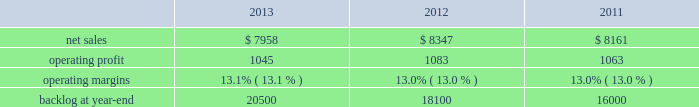Frequency ( aehf ) system , orion , global positioning satellite ( gps ) iii system , geostationary operational environmental satellite r-series ( goes-r ) , and mobile user objective system ( muos ) .
Operating profit for our space systems business segment includes our share of earnings for our investment in united launch alliance ( ula ) , which provides expendable launch services to the u.s .
Government .
Space systems 2019 operating results included the following ( in millions ) : .
2013 compared to 2012 space systems 2019 net sales for 2013 decreased $ 389 million , or 5% ( 5 % ) , compared to 2012 .
The decrease was primarily attributable to lower net sales of approximately $ 305 million for commercial satellite programs due to fewer deliveries ( zero delivered during 2013 compared to two for 2012 ) ; and about $ 290 million for the orion program due to lower volume .
The decreases were partially offset by higher net sales of approximately $ 130 million for government satellite programs due to net increased volume ; and about $ 65 million for strategic and defensive missile programs ( primarily fbm ) due to increased volume and risk retirements .
The increase for government satellite programs was primarily attributable to higher volume on aehf and other programs , partially offset by lower volume on goes-r , muos , and sbirs programs .
Space systems 2019 operating profit for 2013 decreased $ 38 million , or 4% ( 4 % ) , compared to 2012 .
The decrease was primarily attributable to lower operating profit of approximately $ 50 million for the orion program due to lower volume and risk retirements and about $ 30 million for government satellite programs due to decreased risk retirements , which were partially offset by higher equity earnings from joint ventures of approximately $ 35 million .
The decrease in operating profit for government satellite programs was primarily attributable to lower risk retirements for muos , gps iii , and other programs , partially offset by higher risk retirements for the sbirs and aehf programs .
Operating profit for 2013 included about $ 15 million of charges , net of recoveries , related to the november 2013 restructuring plan .
Adjustments not related to volume , including net profit booking rate adjustments and other matters , were approximately $ 15 million lower for 2013 compared to 2012 .
2012 compared to 2011 space systems 2019 net sales for 2012 increased $ 186 million , or 2% ( 2 % ) , compared to 2011 .
The increase was attributable to higher net sales of approximately $ 150 million due to increased commercial satellite deliveries ( two commercial satellites delivered in 2012 compared to one during 2011 ) ; about $ 125 million from the orion program due to higher volume and an increase in risk retirements ; and approximately $ 70 million from increased volume on various strategic and defensive missile programs .
Partially offsetting the increases were lower net sales of approximately $ 105 million from certain government satellite programs ( primarily sbirs and muos ) as a result of decreased volume and a decline in risk retirements ; and about $ 55 million from the nasa external tank program , which ended in connection with the completion of the space shuttle program in 2011 .
Space systems 2019 operating profit for 2012 increased $ 20 million , or 2% ( 2 % ) , compared to 2011 .
The increase was attributable to higher operating profit of approximately $ 60 million from commercial satellite programs due to increased deliveries and reserves recorded in 2011 ; and about $ 40 million from the orion program due to higher risk retirements and increased volume .
Partially offsetting the increases was lower operating profit of approximately $ 45 million from lower volume and risk retirements on certain government satellite programs ( primarily sbirs ) ; about $ 20 million from lower risk retirements and lower volume on the nasa external tank program , which ended in connection with the completion of the space shuttle program in 2011 ; and approximately $ 20 million from lower equity earnings as a decline in launch related activities at ula partially was offset by the resolution of contract cost matters associated with the wind-down of united space alliance ( usa ) .
Adjustments not related to volume , including net profit booking rate adjustments described above , were approximately $ 15 million higher for 2012 compared to 2011 .
Equity earnings total equity earnings recognized by space systems ( primarily ula in 2013 ) represented approximately $ 300 million , or 29% ( 29 % ) of this segment 2019s operating profit during 2013 .
During 2012 and 2011 , total equity earnings recognized by space systems from ula , usa , and the u.k .
Atomic weapons establishment joint venture represented approximately $ 265 million and $ 285 million , or 24% ( 24 % ) and 27% ( 27 % ) of this segment 2019s operating profit. .
What were average net sales for space systems from 2011 to 2013 in millions? 
Computations: table_average(net sales, none)
Answer: 8155.33333. 